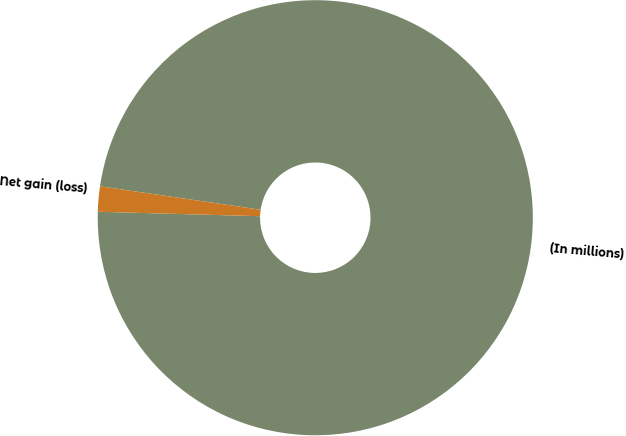Convert chart. <chart><loc_0><loc_0><loc_500><loc_500><pie_chart><fcel>(In millions)<fcel>Net gain (loss)<nl><fcel>98.13%<fcel>1.87%<nl></chart> 